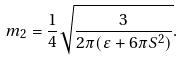<formula> <loc_0><loc_0><loc_500><loc_500>m _ { 2 } = \frac { 1 } { 4 } \sqrt { \frac { 3 } { 2 \pi ( \varepsilon + 6 \pi S ^ { 2 } ) } } .</formula> 